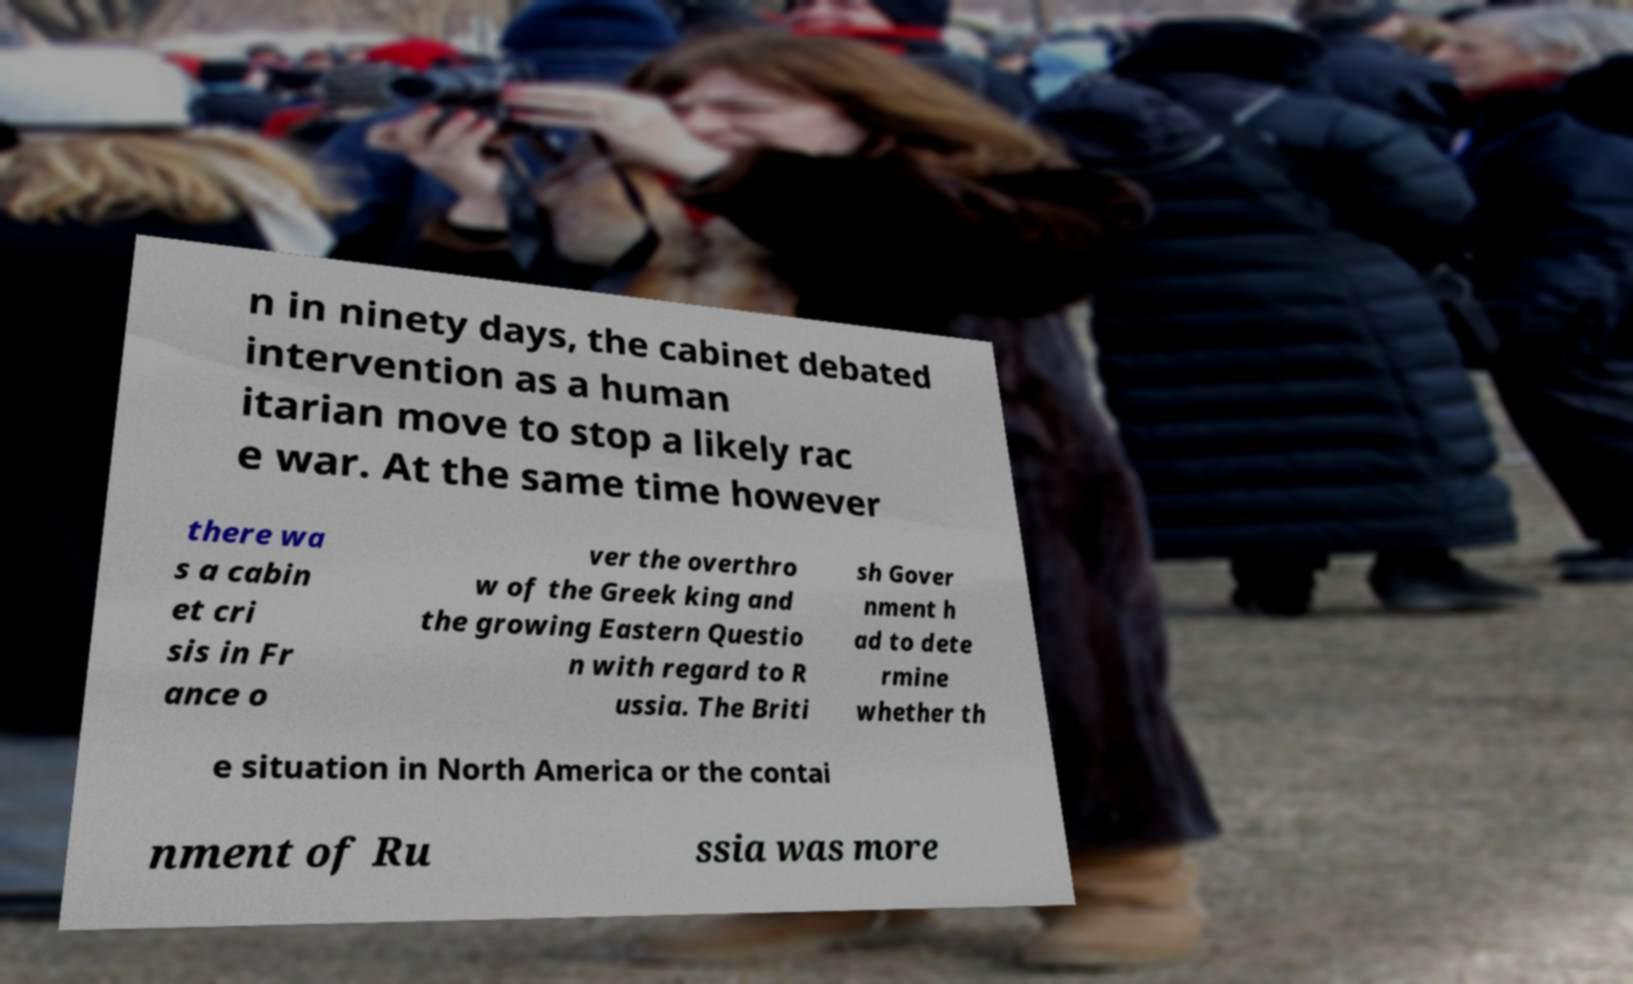Can you accurately transcribe the text from the provided image for me? n in ninety days, the cabinet debated intervention as a human itarian move to stop a likely rac e war. At the same time however there wa s a cabin et cri sis in Fr ance o ver the overthro w of the Greek king and the growing Eastern Questio n with regard to R ussia. The Briti sh Gover nment h ad to dete rmine whether th e situation in North America or the contai nment of Ru ssia was more 